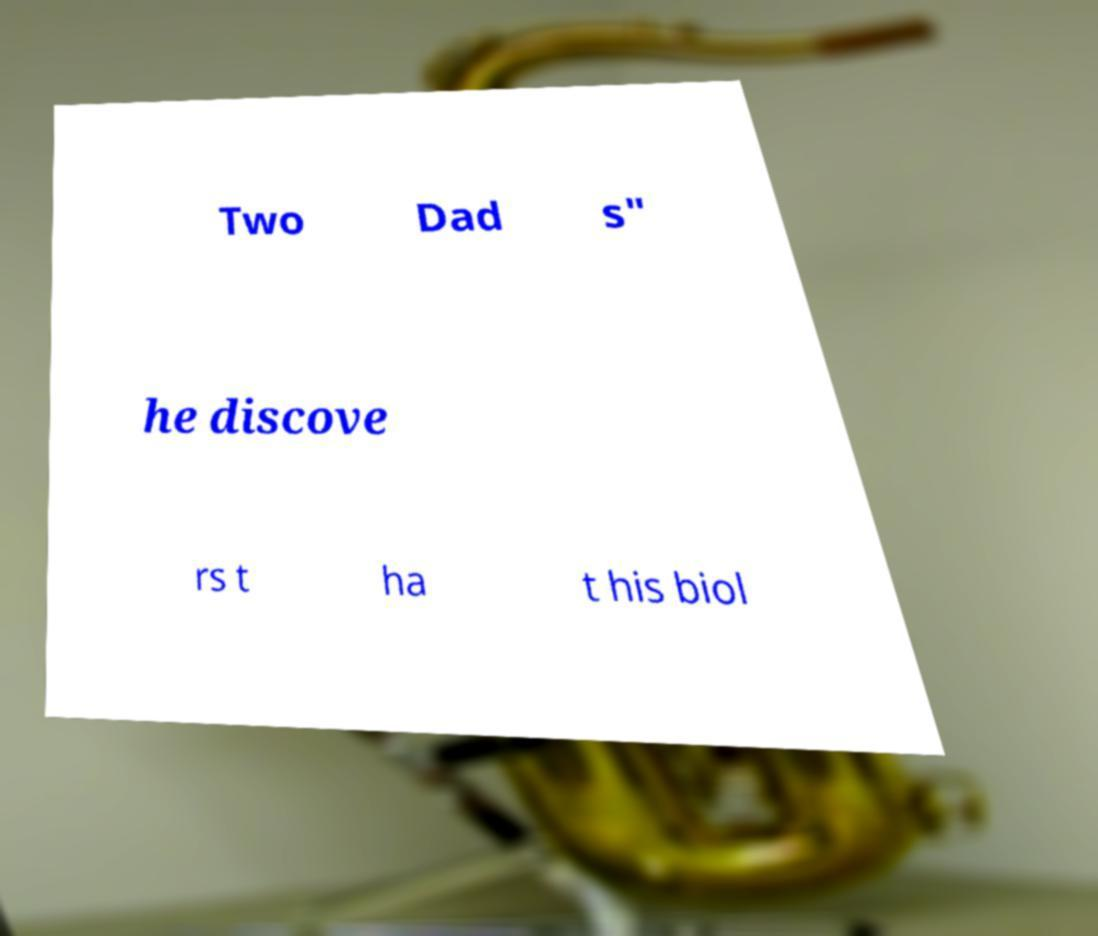What messages or text are displayed in this image? I need them in a readable, typed format. Two Dad s" he discove rs t ha t his biol 